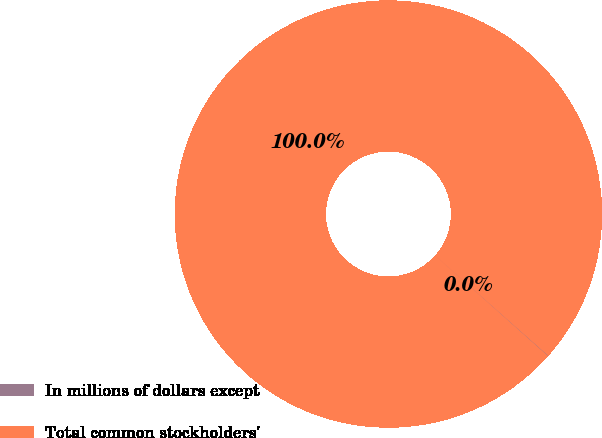Convert chart to OTSL. <chart><loc_0><loc_0><loc_500><loc_500><pie_chart><fcel>In millions of dollars except<fcel>Total common stockholders'<nl><fcel>0.04%<fcel>99.96%<nl></chart> 